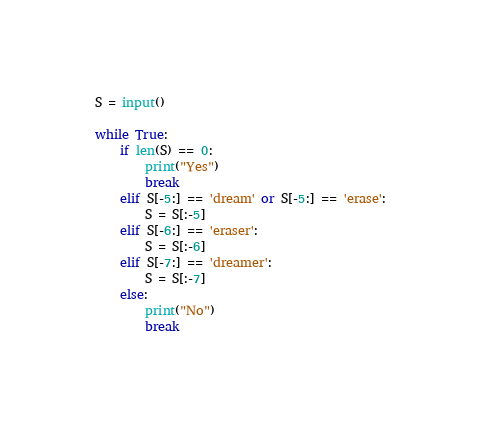<code> <loc_0><loc_0><loc_500><loc_500><_Python_>S = input()

while True:
    if len(S) == 0:
        print("Yes")
        break
    elif S[-5:] == 'dream' or S[-5:] == 'erase':
        S = S[:-5]
    elif S[-6:] == 'eraser':
        S = S[:-6]
    elif S[-7:] == 'dreamer':
        S = S[:-7]
    else:
        print("No")
        break</code> 